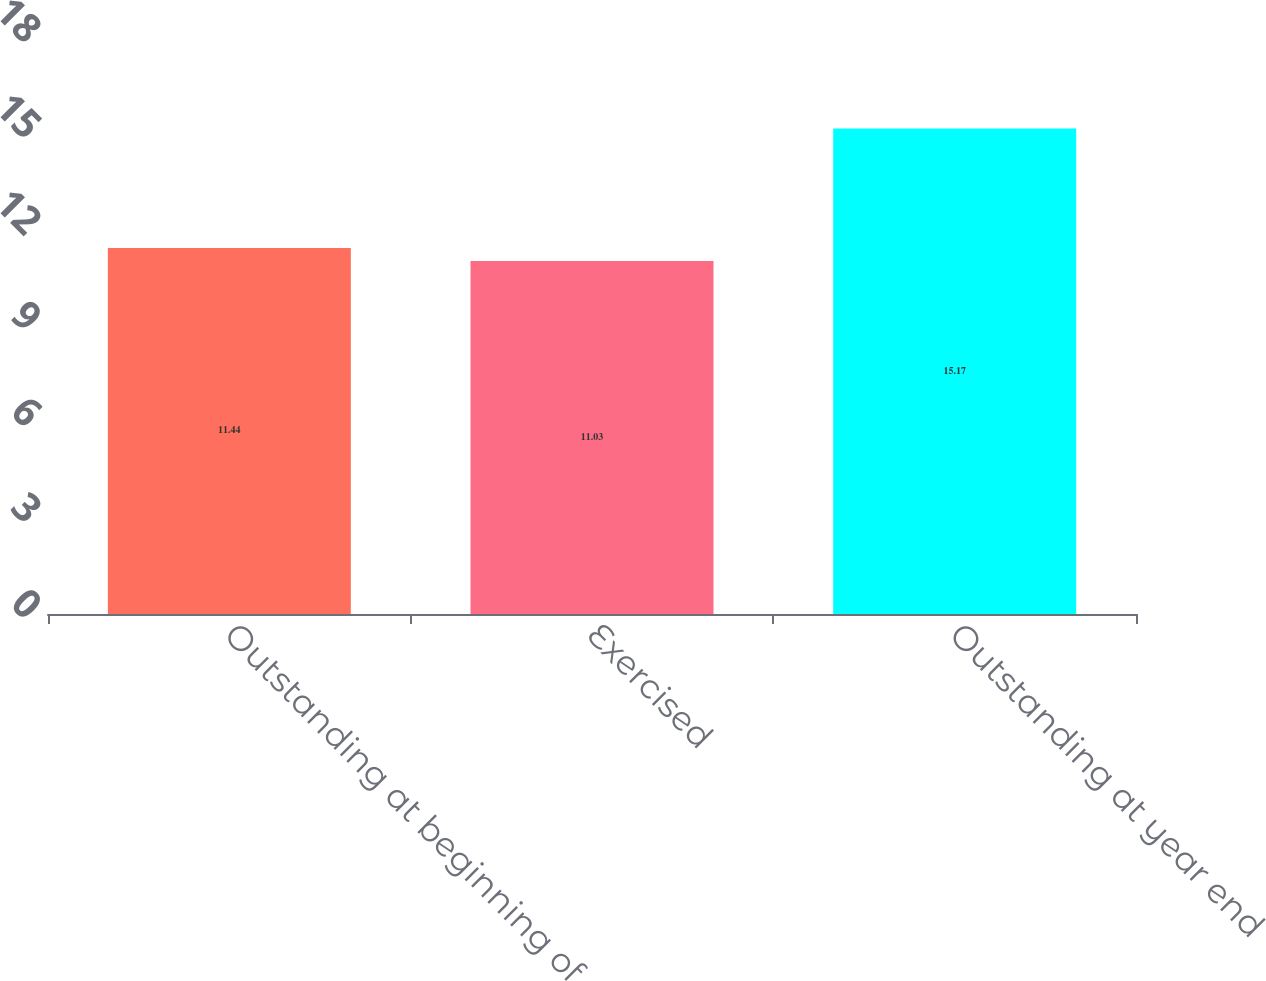Convert chart to OTSL. <chart><loc_0><loc_0><loc_500><loc_500><bar_chart><fcel>Outstanding at beginning of<fcel>Exercised<fcel>Outstanding at year end<nl><fcel>11.44<fcel>11.03<fcel>15.17<nl></chart> 